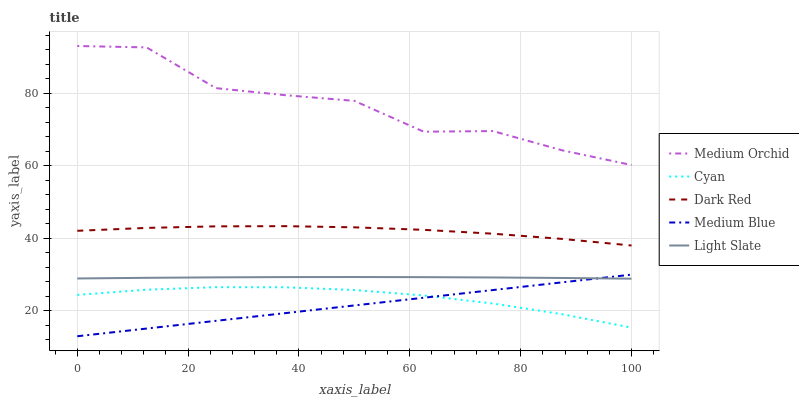Does Medium Blue have the minimum area under the curve?
Answer yes or no. Yes. Does Medium Orchid have the maximum area under the curve?
Answer yes or no. Yes. Does Cyan have the minimum area under the curve?
Answer yes or no. No. Does Cyan have the maximum area under the curve?
Answer yes or no. No. Is Medium Blue the smoothest?
Answer yes or no. Yes. Is Medium Orchid the roughest?
Answer yes or no. Yes. Is Cyan the smoothest?
Answer yes or no. No. Is Cyan the roughest?
Answer yes or no. No. Does Medium Blue have the lowest value?
Answer yes or no. Yes. Does Cyan have the lowest value?
Answer yes or no. No. Does Medium Orchid have the highest value?
Answer yes or no. Yes. Does Cyan have the highest value?
Answer yes or no. No. Is Medium Blue less than Medium Orchid?
Answer yes or no. Yes. Is Medium Orchid greater than Cyan?
Answer yes or no. Yes. Does Cyan intersect Medium Blue?
Answer yes or no. Yes. Is Cyan less than Medium Blue?
Answer yes or no. No. Is Cyan greater than Medium Blue?
Answer yes or no. No. Does Medium Blue intersect Medium Orchid?
Answer yes or no. No. 